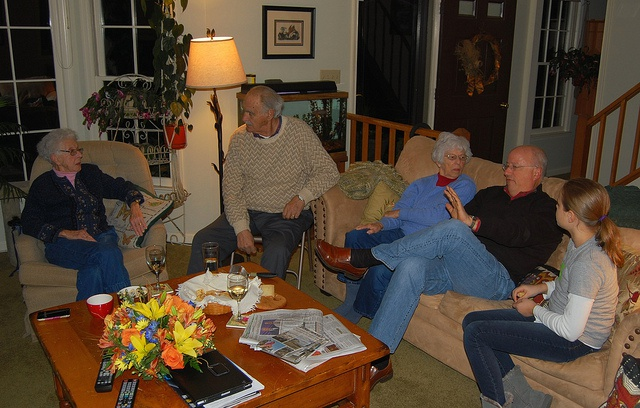Describe the objects in this image and their specific colors. I can see dining table in black, maroon, and darkgray tones, couch in black, maroon, and gray tones, people in black, blue, and gray tones, people in black, gray, and darkgray tones, and people in black, gray, and maroon tones in this image. 